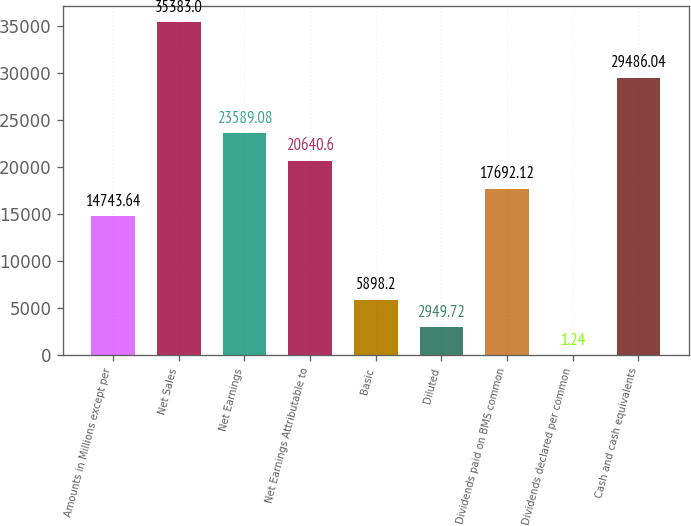<chart> <loc_0><loc_0><loc_500><loc_500><bar_chart><fcel>Amounts in Millions except per<fcel>Net Sales<fcel>Net Earnings<fcel>Net Earnings Attributable to<fcel>Basic<fcel>Diluted<fcel>Dividends paid on BMS common<fcel>Dividends declared per common<fcel>Cash and cash equivalents<nl><fcel>14743.6<fcel>35383<fcel>23589.1<fcel>20640.6<fcel>5898.2<fcel>2949.72<fcel>17692.1<fcel>1.24<fcel>29486<nl></chart> 